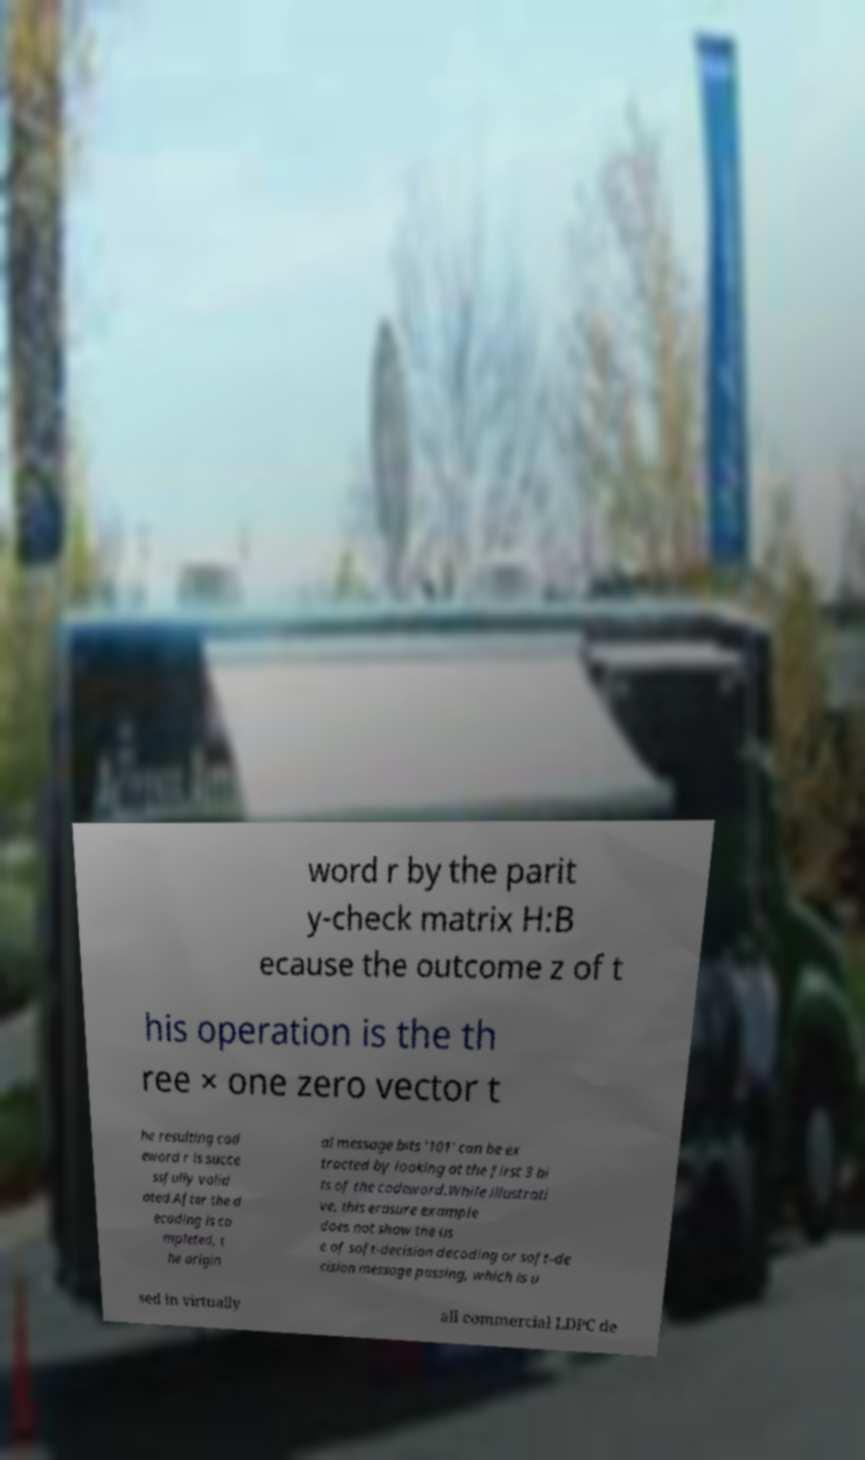Could you assist in decoding the text presented in this image and type it out clearly? word r by the parit y-check matrix H:B ecause the outcome z of t his operation is the th ree × one zero vector t he resulting cod eword r is succe ssfully valid ated.After the d ecoding is co mpleted, t he origin al message bits '101' can be ex tracted by looking at the first 3 bi ts of the codeword.While illustrati ve, this erasure example does not show the us e of soft-decision decoding or soft-de cision message passing, which is u sed in virtually all commercial LDPC de 